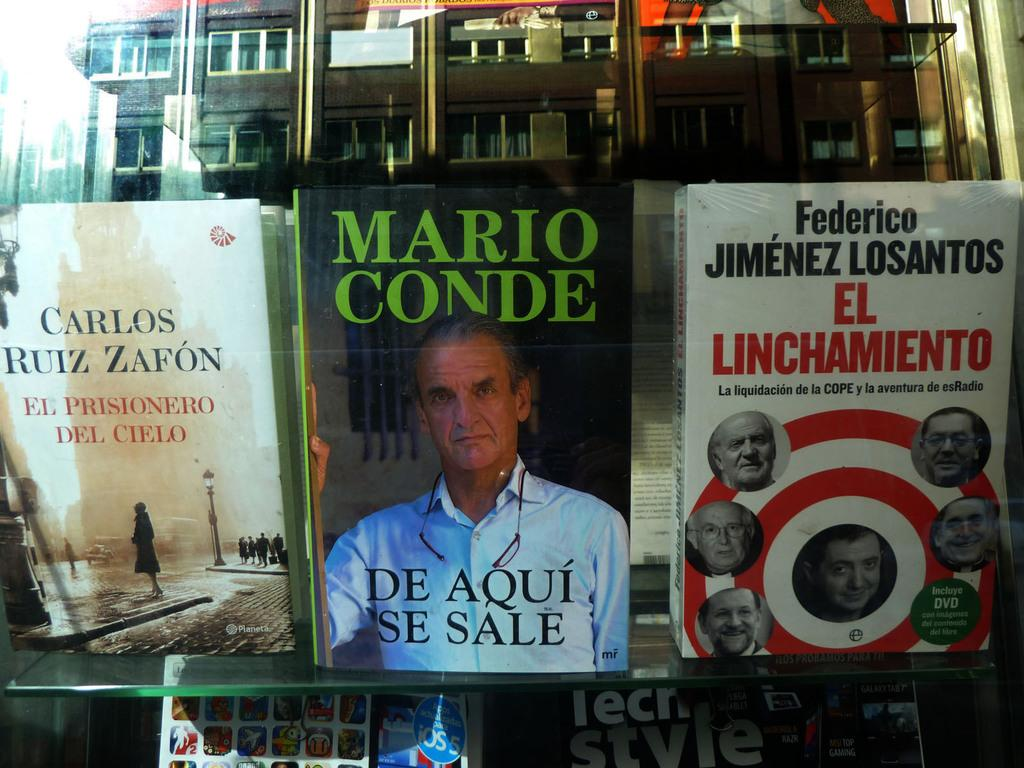<image>
Offer a succinct explanation of the picture presented. A book titled Mario Conde by Des Aqui Se Sale 